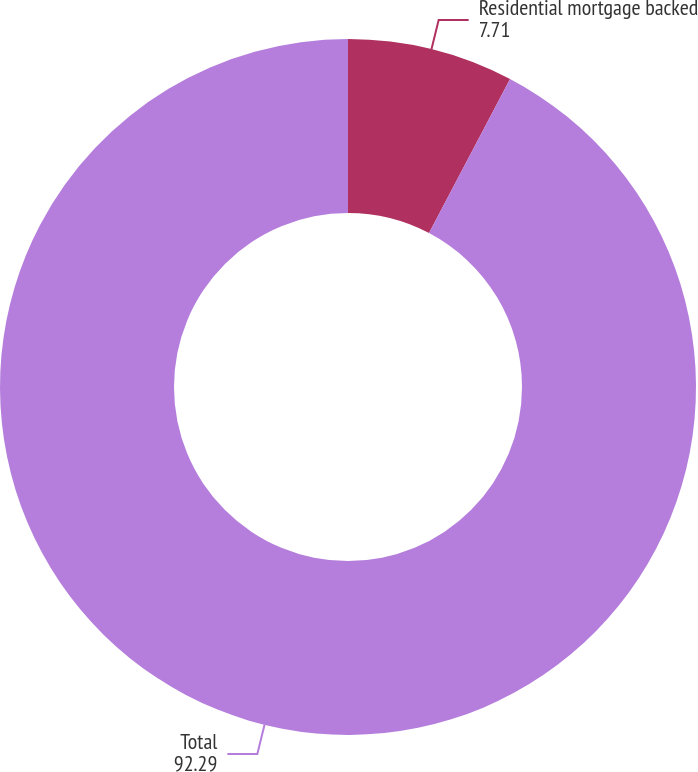Convert chart to OTSL. <chart><loc_0><loc_0><loc_500><loc_500><pie_chart><fcel>Residential mortgage backed<fcel>Total<nl><fcel>7.71%<fcel>92.29%<nl></chart> 